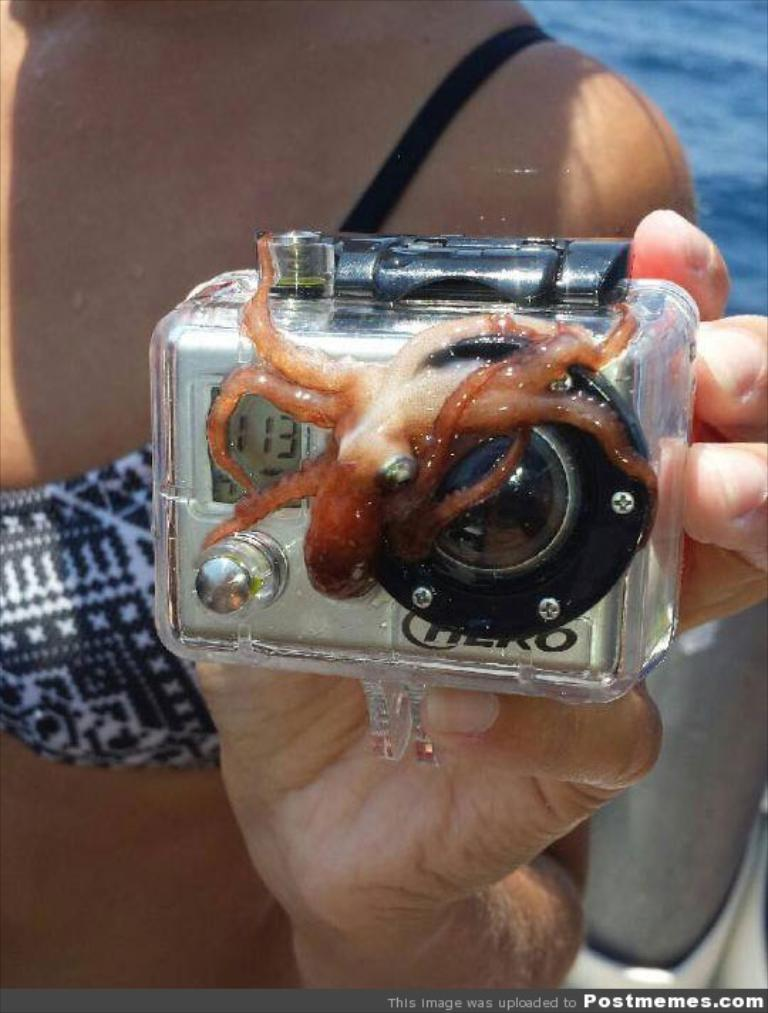What can be seen in the image? There is a person in the image. What is the person holding? The person is holding an object. What is visible in the background of the image? There is water visible behind the person. Can you describe the object in the bottom right of the image? There is an object in the bottom right of the image. What type of toothpaste is being distributed through the hole in the image? There is no toothpaste or hole present in the image. 